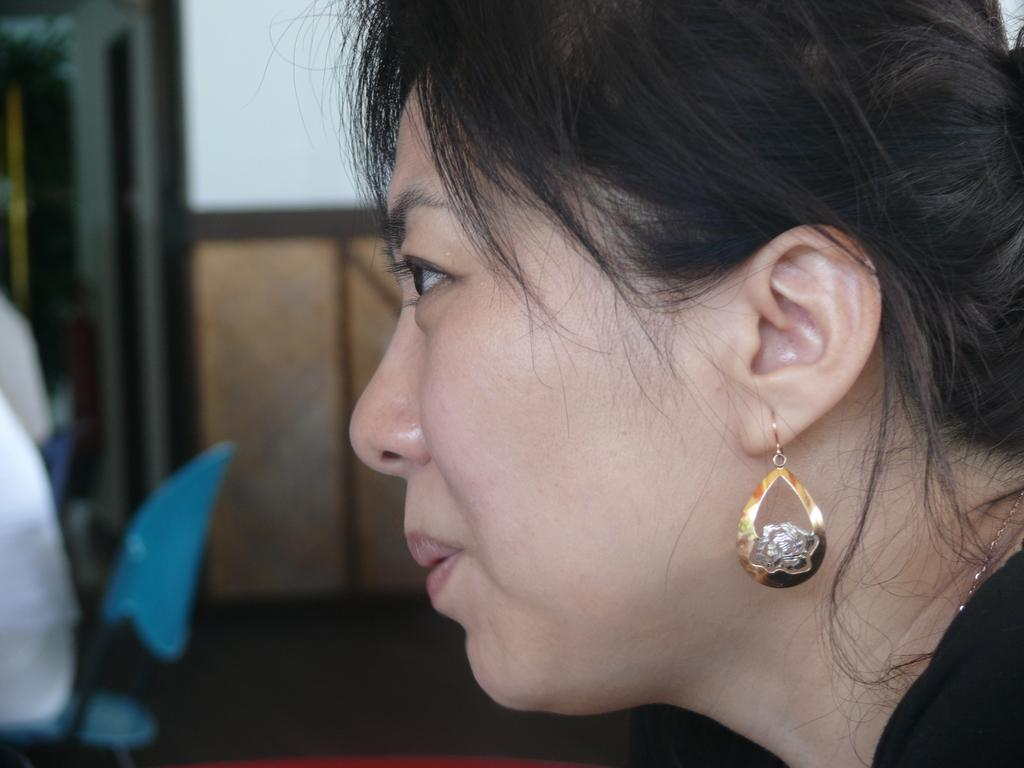What is the main subject of the image? There is a person's face in the image. Can you describe any objects in the image? There is a chair in the bottom left of the image. How would you describe the background of the image? The background of the image is blurred. What type of condition does the person's face have in the image? There is no indication of any specific condition in the image; it simply shows a person's face. How many spiders can be seen on the person's face in the image? There are no spiders present on the person's face in the image. 